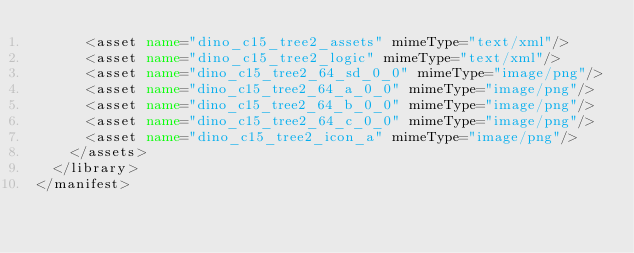<code> <loc_0><loc_0><loc_500><loc_500><_XML_>      <asset name="dino_c15_tree2_assets" mimeType="text/xml"/>
      <asset name="dino_c15_tree2_logic" mimeType="text/xml"/>
      <asset name="dino_c15_tree2_64_sd_0_0" mimeType="image/png"/>
      <asset name="dino_c15_tree2_64_a_0_0" mimeType="image/png"/>
      <asset name="dino_c15_tree2_64_b_0_0" mimeType="image/png"/>
      <asset name="dino_c15_tree2_64_c_0_0" mimeType="image/png"/>
      <asset name="dino_c15_tree2_icon_a" mimeType="image/png"/>
    </assets>
  </library>
</manifest></code> 